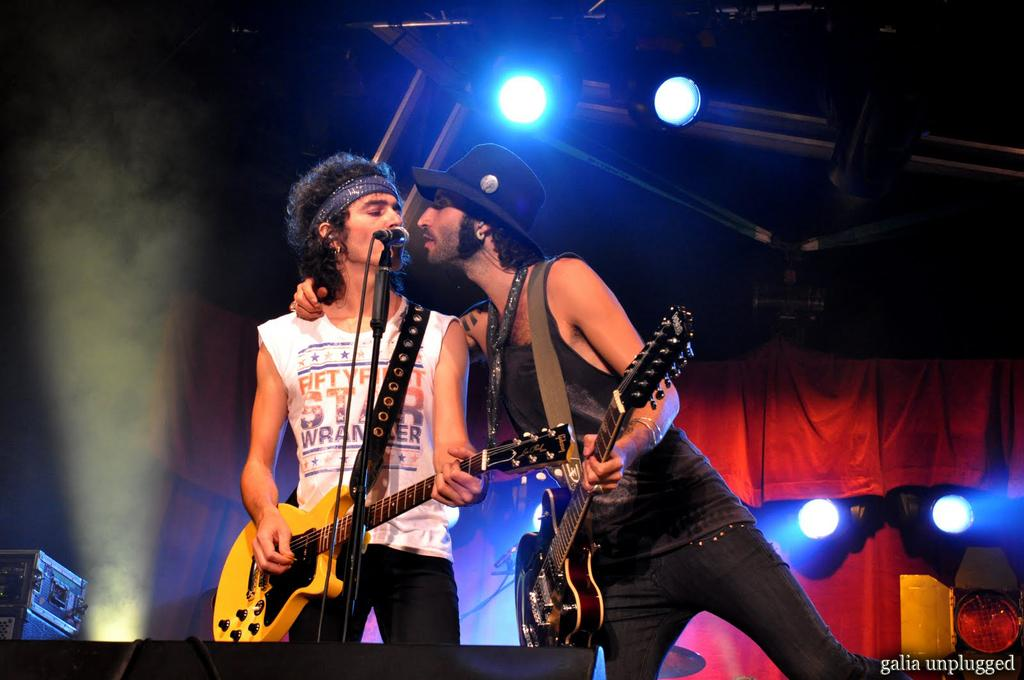How many people are in the image? There are two men in the image. What are the men holding in the image? The men are holding guitars. What can be seen in front of the men in the image? The men are standing in front of a microphone. What is visible in the background of the image? There are lights visible in the background of the image. Is there a girl playing with a steel sign in the image? No, there is no girl or steel sign present in the image. 